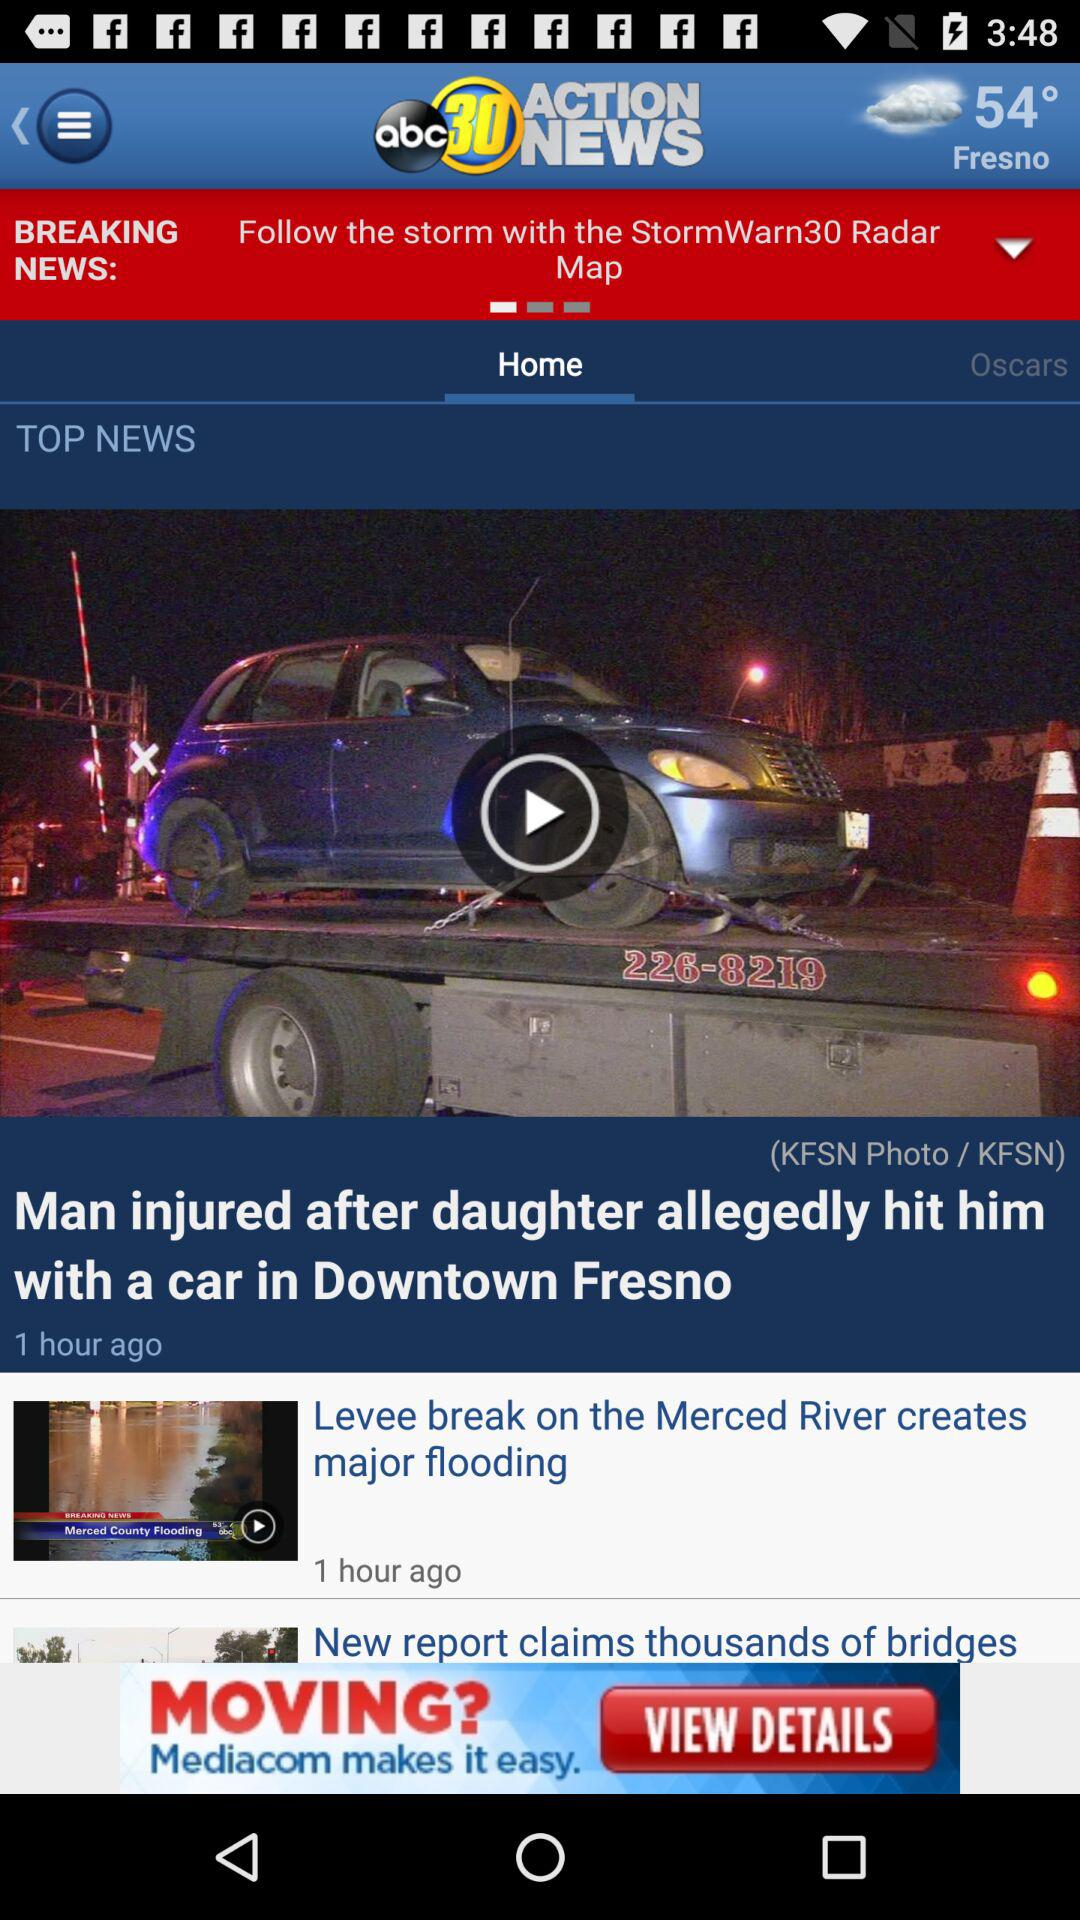Which tab has been selected? The selected tab is "Home". 